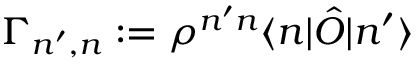Convert formula to latex. <formula><loc_0><loc_0><loc_500><loc_500>\Gamma _ { n ^ { \prime } , n } \colon = \rho ^ { n ^ { \prime } n } \langle n | \hat { O } | n ^ { \prime } \rangle</formula> 